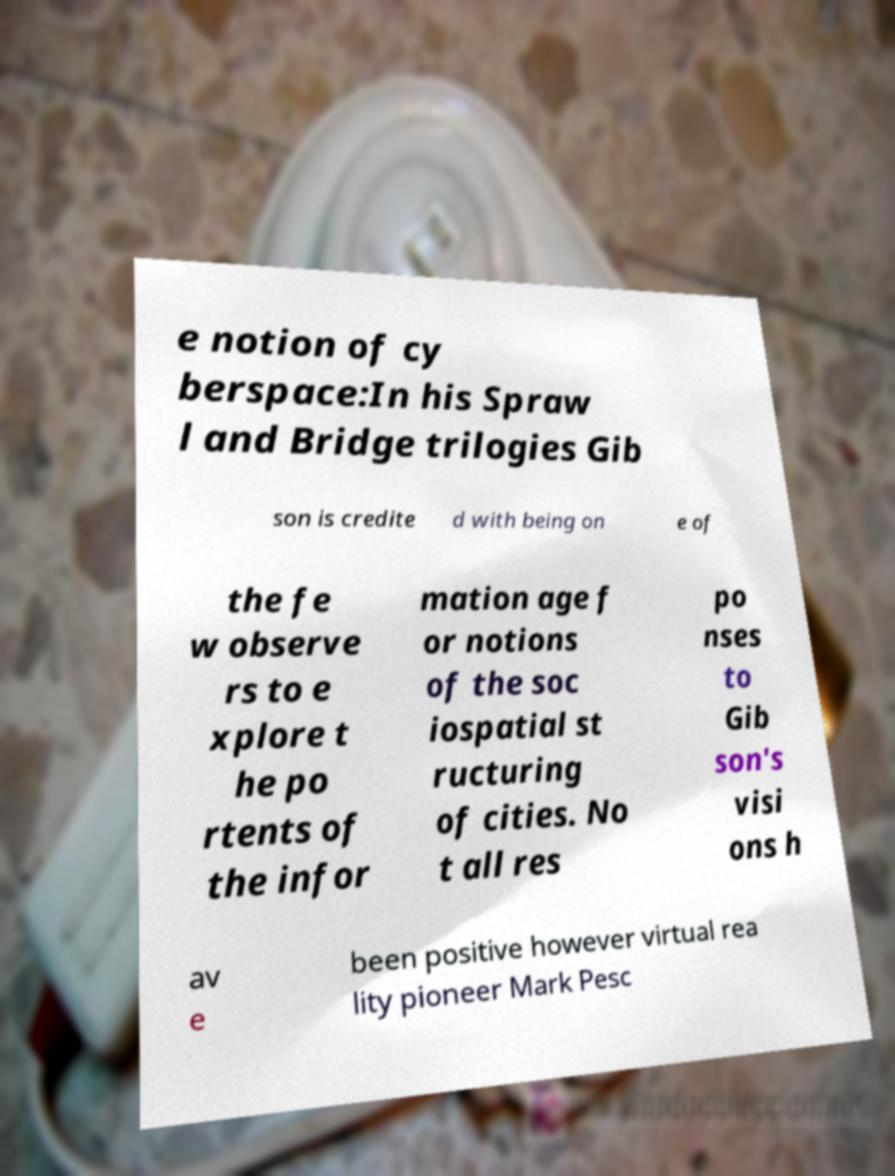Could you extract and type out the text from this image? e notion of cy berspace:In his Spraw l and Bridge trilogies Gib son is credite d with being on e of the fe w observe rs to e xplore t he po rtents of the infor mation age f or notions of the soc iospatial st ructuring of cities. No t all res po nses to Gib son's visi ons h av e been positive however virtual rea lity pioneer Mark Pesc 